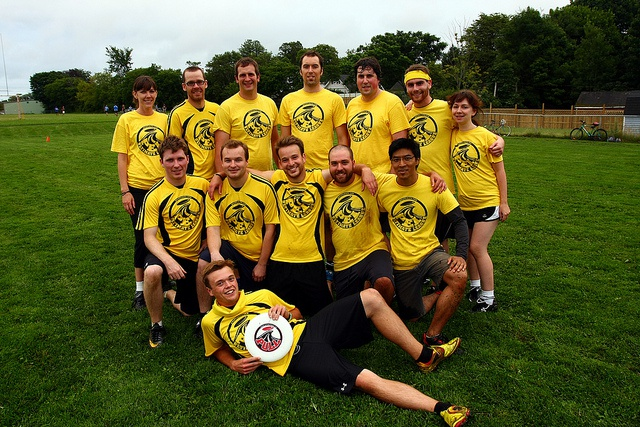Describe the objects in this image and their specific colors. I can see people in white, black, maroon, brown, and ivory tones, people in white, black, maroon, gold, and olive tones, people in white, black, maroon, gold, and orange tones, people in white, black, gold, and olive tones, and people in white, black, orange, olive, and maroon tones in this image. 